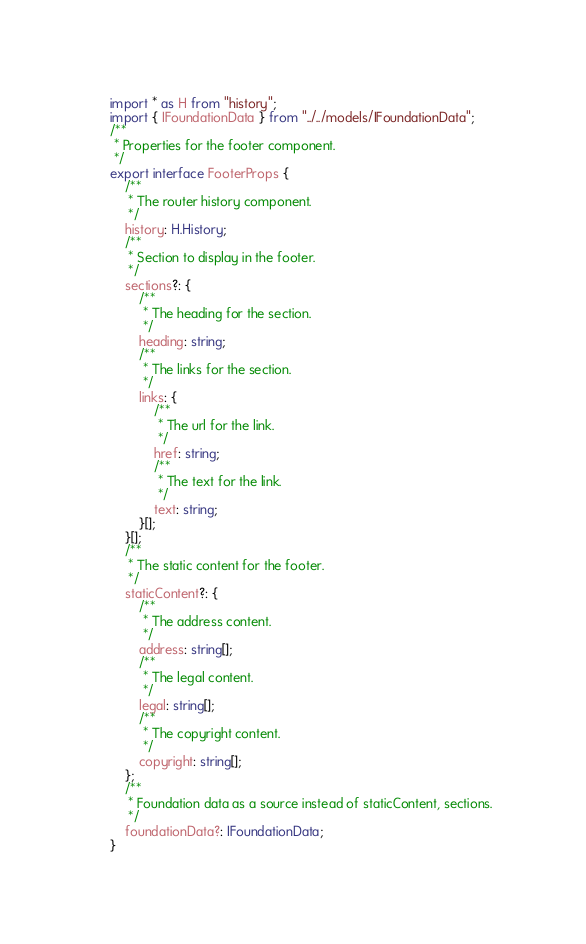<code> <loc_0><loc_0><loc_500><loc_500><_TypeScript_>import * as H from "history";
import { IFoundationData } from "../../models/IFoundationData";
/**
 * Properties for the footer component.
 */
export interface FooterProps {
    /**
     * The router history component.
     */
    history: H.History;
    /**
     * Section to display in the footer.
     */
    sections?: {
        /**
         * The heading for the section.
         */
        heading: string;
        /**
         * The links for the section.
         */
        links: {
            /**
             * The url for the link.
             */
            href: string;
            /**
             * The text for the link.
             */
            text: string;
        }[];
    }[];
    /**
     * The static content for the footer.
     */
    staticContent?: {
        /**
         * The address content.
         */
        address: string[];
        /**
         * The legal content.
         */
        legal: string[];
        /**
         * The copyright content.
         */
        copyright: string[];
    };
    /**
     * Foundation data as a source instead of staticContent, sections.
     */
    foundationData?: IFoundationData;
}
</code> 